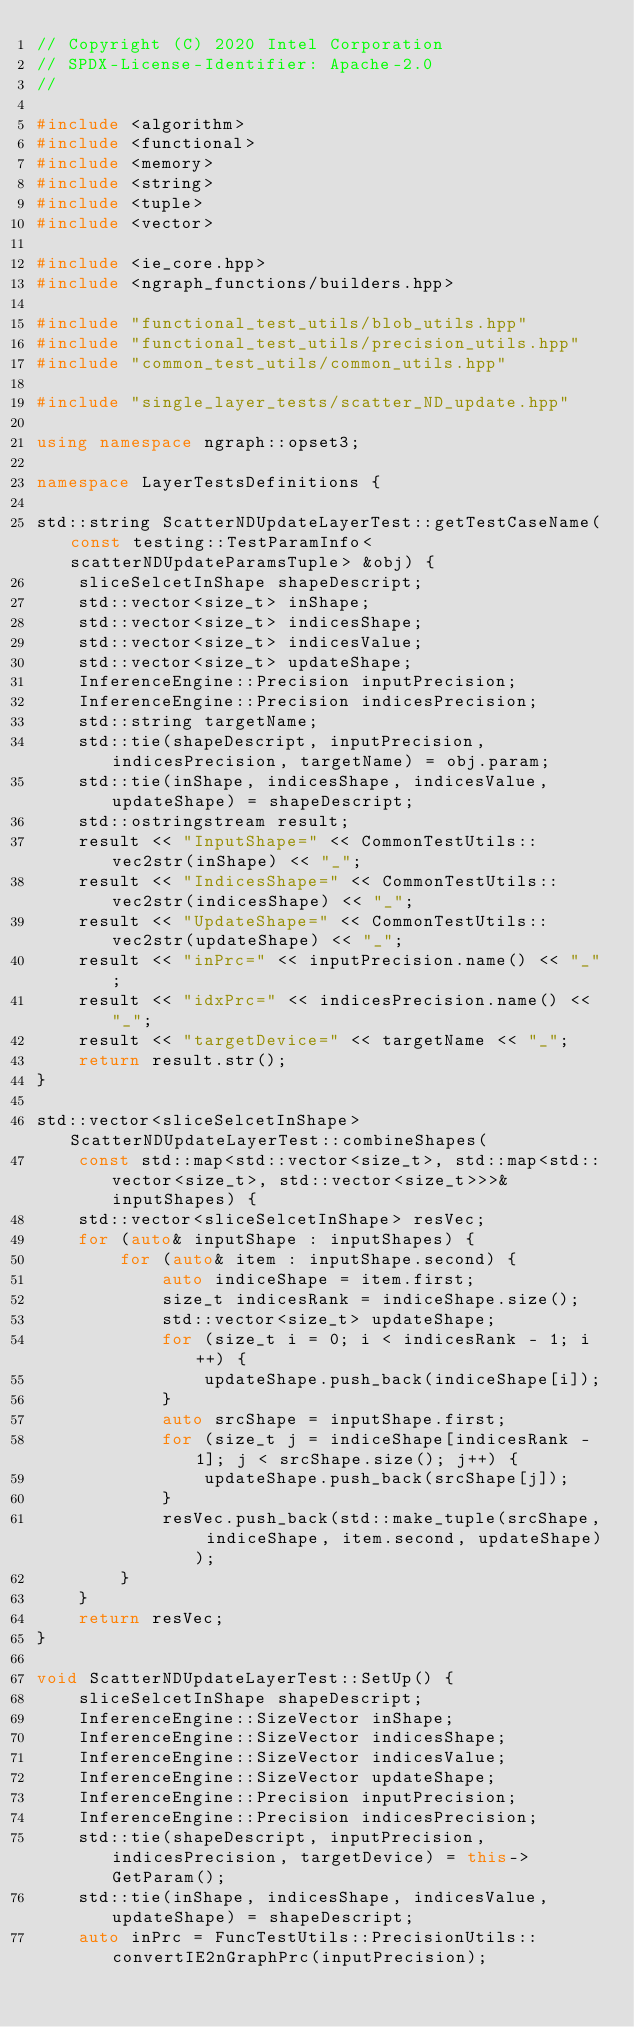<code> <loc_0><loc_0><loc_500><loc_500><_C++_>// Copyright (C) 2020 Intel Corporation
// SPDX-License-Identifier: Apache-2.0
//

#include <algorithm>
#include <functional>
#include <memory>
#include <string>
#include <tuple>
#include <vector>

#include <ie_core.hpp>
#include <ngraph_functions/builders.hpp>

#include "functional_test_utils/blob_utils.hpp"
#include "functional_test_utils/precision_utils.hpp"
#include "common_test_utils/common_utils.hpp"

#include "single_layer_tests/scatter_ND_update.hpp"

using namespace ngraph::opset3;

namespace LayerTestsDefinitions {

std::string ScatterNDUpdateLayerTest::getTestCaseName(const testing::TestParamInfo<scatterNDUpdateParamsTuple> &obj) {
    sliceSelcetInShape shapeDescript;
    std::vector<size_t> inShape;
    std::vector<size_t> indicesShape;
    std::vector<size_t> indicesValue;
    std::vector<size_t> updateShape;
    InferenceEngine::Precision inputPrecision;
    InferenceEngine::Precision indicesPrecision;
    std::string targetName;
    std::tie(shapeDescript, inputPrecision, indicesPrecision, targetName) = obj.param;
    std::tie(inShape, indicesShape, indicesValue, updateShape) = shapeDescript;
    std::ostringstream result;
    result << "InputShape=" << CommonTestUtils::vec2str(inShape) << "_";
    result << "IndicesShape=" << CommonTestUtils::vec2str(indicesShape) << "_";
    result << "UpdateShape=" << CommonTestUtils::vec2str(updateShape) << "_";
    result << "inPrc=" << inputPrecision.name() << "_";
    result << "idxPrc=" << indicesPrecision.name() << "_";
    result << "targetDevice=" << targetName << "_";
    return result.str();
}

std::vector<sliceSelcetInShape> ScatterNDUpdateLayerTest::combineShapes(
    const std::map<std::vector<size_t>, std::map<std::vector<size_t>, std::vector<size_t>>>& inputShapes) {
    std::vector<sliceSelcetInShape> resVec;
    for (auto& inputShape : inputShapes) {
        for (auto& item : inputShape.second) {
            auto indiceShape = item.first;
            size_t indicesRank = indiceShape.size();
            std::vector<size_t> updateShape;
            for (size_t i = 0; i < indicesRank - 1; i++) {
                updateShape.push_back(indiceShape[i]);
            }
            auto srcShape = inputShape.first;
            for (size_t j = indiceShape[indicesRank - 1]; j < srcShape.size(); j++) {
                updateShape.push_back(srcShape[j]);
            }
            resVec.push_back(std::make_tuple(srcShape, indiceShape, item.second, updateShape));
        }
    }
    return resVec;
}

void ScatterNDUpdateLayerTest::SetUp() {
    sliceSelcetInShape shapeDescript;
    InferenceEngine::SizeVector inShape;
    InferenceEngine::SizeVector indicesShape;
    InferenceEngine::SizeVector indicesValue;
    InferenceEngine::SizeVector updateShape;
    InferenceEngine::Precision inputPrecision;
    InferenceEngine::Precision indicesPrecision;
    std::tie(shapeDescript, inputPrecision, indicesPrecision, targetDevice) = this->GetParam();
    std::tie(inShape, indicesShape, indicesValue, updateShape) = shapeDescript;
    auto inPrc = FuncTestUtils::PrecisionUtils::convertIE2nGraphPrc(inputPrecision);</code> 